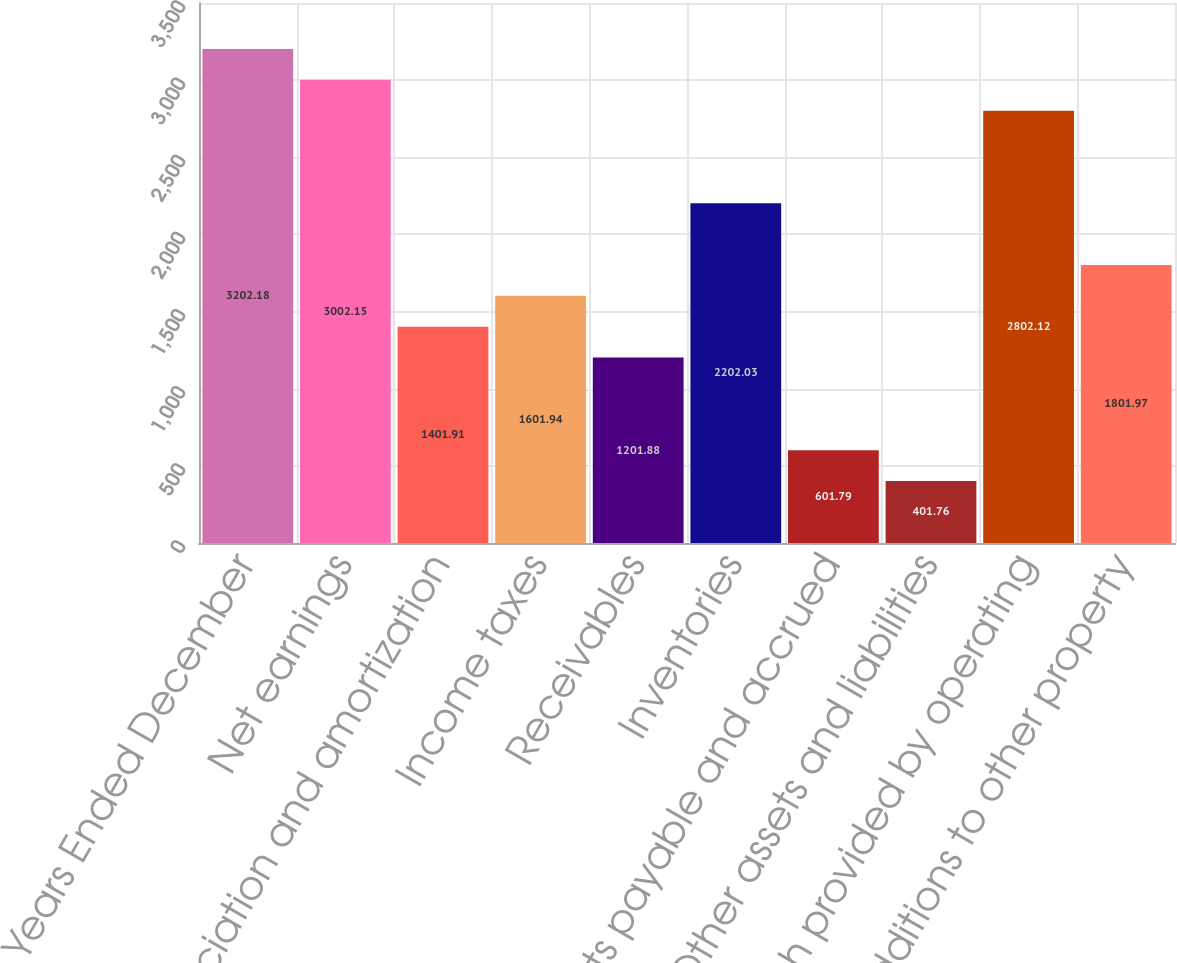<chart> <loc_0><loc_0><loc_500><loc_500><bar_chart><fcel>For the Years Ended December<fcel>Net earnings<fcel>Depreciation and amortization<fcel>Income taxes<fcel>Receivables<fcel>Inventories<fcel>Accounts payable and accrued<fcel>Other assets and liabilities<fcel>Net cash provided by operating<fcel>Additions to other property<nl><fcel>3202.18<fcel>3002.15<fcel>1401.91<fcel>1601.94<fcel>1201.88<fcel>2202.03<fcel>601.79<fcel>401.76<fcel>2802.12<fcel>1801.97<nl></chart> 